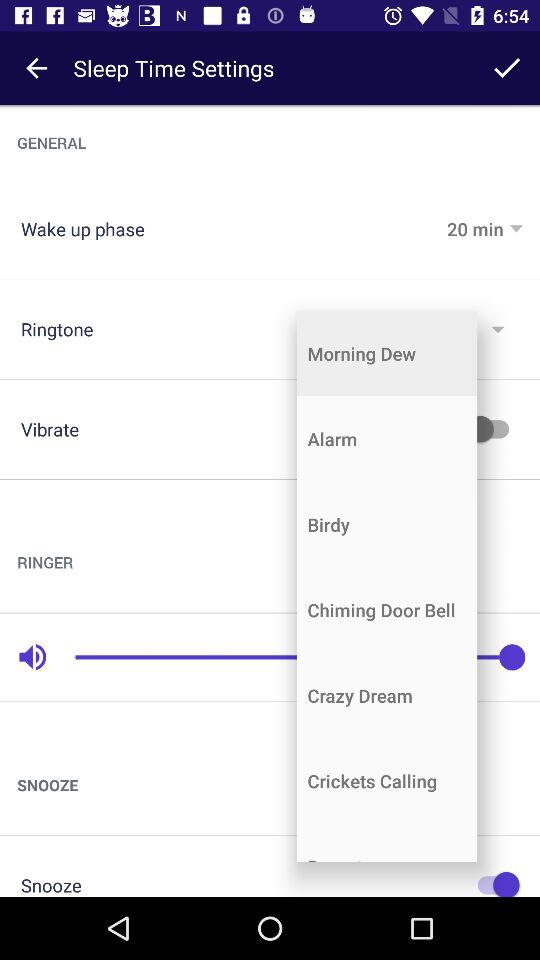What is the status of "Snooze"? The status is "on". 